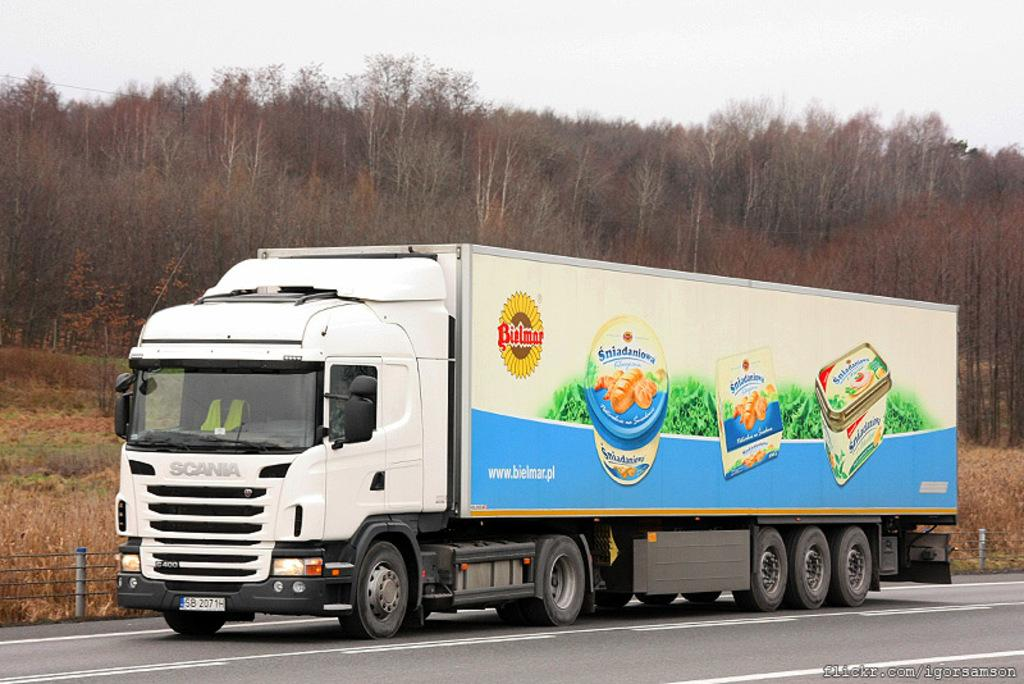What is the main subject of the image? The main subject of the image is a truck. Where is the truck located in the image? The truck is on the road in the image. What can be seen in the background of the image? There are trees, plants, grass, and the sky visible in the background of the image. What is the truck's aunt doing in the image? There is no mention of an aunt in the image, and therefore no such activity can be observed. 